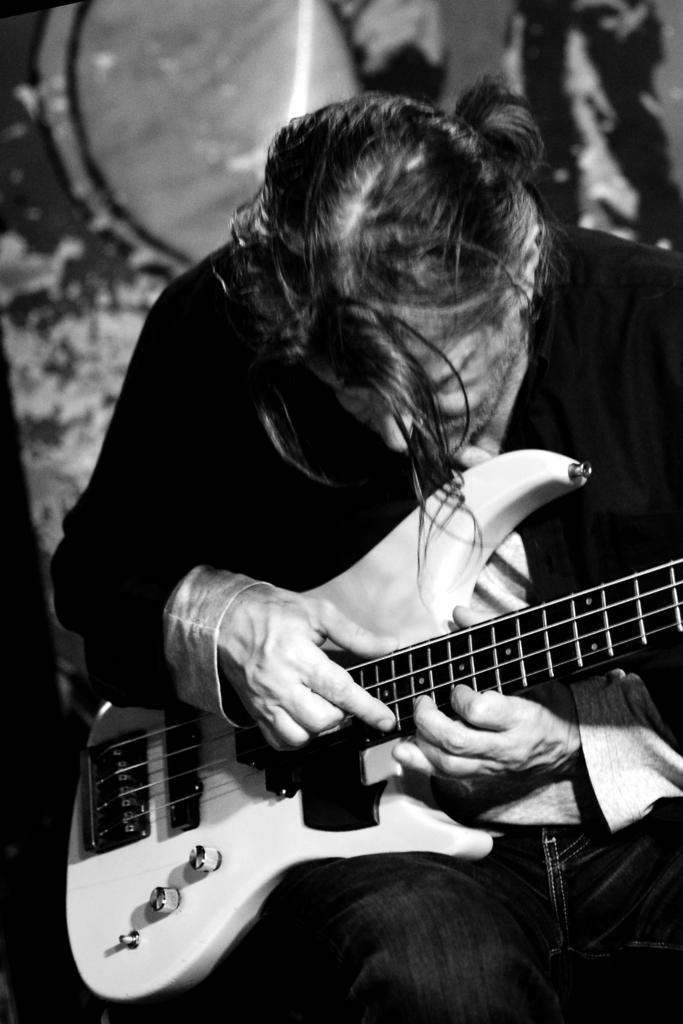What is the color scheme of the image? The image is black and white. Who is present in the image? There is a man in the image. What is the man doing in the image? The man is sitting and playing a guitar. What type of steel is the tiger made of in the image? There is no tiger present in the image, and therefore no steel or any other material associated with it. 